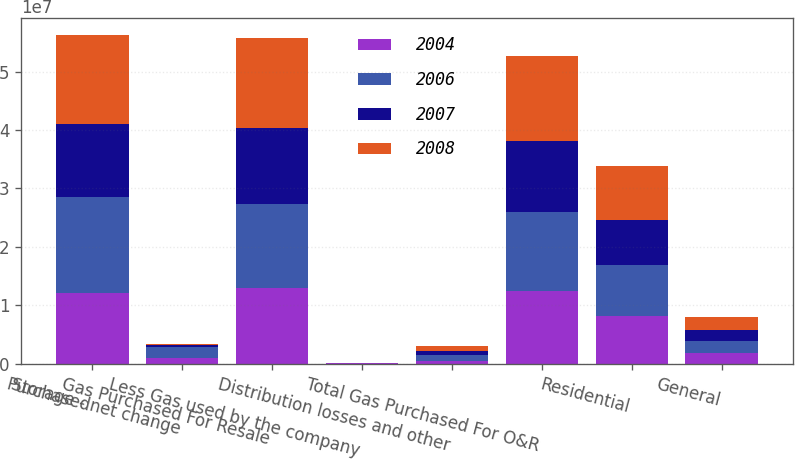Convert chart. <chart><loc_0><loc_0><loc_500><loc_500><stacked_bar_chart><ecel><fcel>Purchased<fcel>Storage - net change<fcel>Gas Purchased For Resale<fcel>Less Gas used by the company<fcel>Distribution losses and other<fcel>Total Gas Purchased For O&R<fcel>Residential<fcel>General<nl><fcel>2004<fcel>1.20388e+07<fcel>892058<fcel>1.29308e+07<fcel>46232<fcel>433738<fcel>1.24509e+07<fcel>8.06817e+06<fcel>1.816e+06<nl><fcel>2006<fcel>1.64127e+07<fcel>1.95096e+06<fcel>1.44618e+07<fcel>38268<fcel>937526<fcel>1.3486e+07<fcel>8.76883e+06<fcel>2.06563e+06<nl><fcel>2007<fcel>1.25824e+07<fcel>409333<fcel>1.29917e+07<fcel>37630<fcel>703676<fcel>1.22504e+07<fcel>7.75844e+06<fcel>1.89156e+06<nl><fcel>2008<fcel>1.53298e+07<fcel>121547<fcel>1.54514e+07<fcel>48410<fcel>848790<fcel>1.45542e+07<fcel>9.30659e+06<fcel>2.26921e+06<nl></chart> 